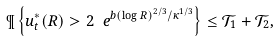Convert formula to latex. <formula><loc_0><loc_0><loc_500><loc_500>\P \left \{ u _ { t } ^ { * } ( R ) > 2 \ e ^ { b ( \log R ) ^ { 2 / 3 } / \kappa ^ { 1 / 3 } } \right \} \leq \mathcal { T } _ { 1 } + \mathcal { T } _ { 2 } ,</formula> 